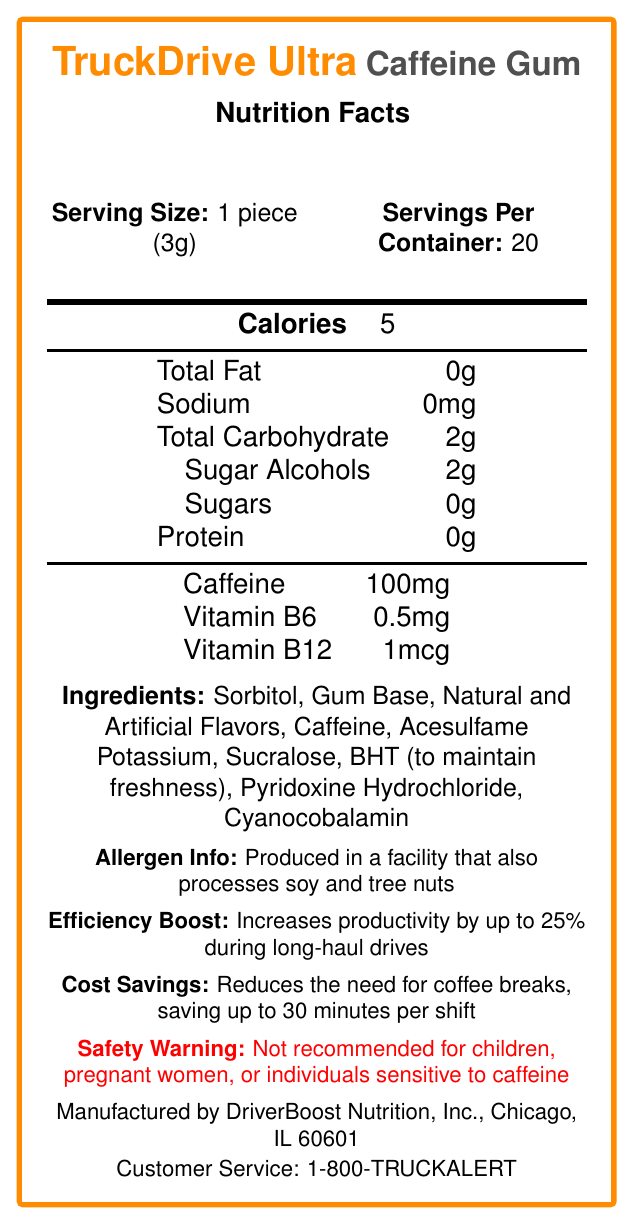what is the serving size? The document states that the serving size is 1 piece (3g).
Answer: 1 piece (3g) how many servings are there per container? According to the document, there are 20 servings per container.
Answer: 20 what is the amount of caffeine per serving? The document specifies that each serving contains 100mg of caffeine.
Answer: 100mg how many calories are in one serving? The document states that one serving contains 5 calories.
Answer: 5 what are the main ingredients of the product? The document lists the ingredients as Sorbitol, Gum Base, Natural and Artificial Flavors, Caffeine, Acesulfame Potassium, Sucralose, BHT (to maintain freshness), Pyridoxine Hydrochloride, Cyanocobalamin.
Answer: Sorbitol, Gum Base, Natural and Artificial Flavors, Caffeine, Acesulfame Potassium, Sucralose, BHT (to maintain freshness), Pyridoxine Hydrochloride, Cyanocobalamin what is the peak alertness duration provided by this gum? The document mentions that the peak alertness duration is 3-4 hours.
Answer: 3-4 hours what type of vitamins are included in TruckDrive Ultra Caffeine Gum? The document lists Vitamin B6 (0.5mg) and Vitamin B12 (1mcg) among the nutrients.
Answer: Vitamin B6 and Vitamin B12 what is the recommended chew time for this gum? The recommended chew time mentioned in the document is 15-20 minutes.
Answer: 15-20 minutes are there any allergens present in the product? The document states that the product is produced in a facility that also processes soy and tree nuts.
Answer: Produced in a facility that also processes soy and tree nuts what is the advised storage method for this product? According to the document, the storage instructions are to store the gum in a cool, dry place away from direct sunlight.
Answer: Store in a cool, dry place away from direct sunlight how much sugar is in one serving? The document indicates that there are 0 grams of sugar per serving.
Answer: 0g which of the following is not an ingredient in TruckDrive Ultra Caffeine Gum? A. Sorbitol B. Gum Base C. Caffeine D. Aspartame E. Sucralose The list of ingredients in the document does not include aspartame.
Answer: D. Aspartame what percentage of recycled materials is used in the packaging? A. 20% B. 30% C. 40% D. 50% The document states that the packaging is made from 30% recycled materials.
Answer: B. 30% is this product suitable for drivers? The document claims that the product is suitable for drivers.
Answer: Yes describe the main idea of the document. The document provides detailed information about the nutritional content, recommended usage, and benefits of TruckDrive Ultra Caffeine Gum while highlighting its target audience and necessary precautions.
Answer: The document describes the nutrition facts, ingredients, and benefits of "TruckDrive Ultra Caffeine Gum," which is designed to enhance alertness and productivity for long-haul drivers, along with providing necessary safety warnings and storage instructions. what is the manufacturing date of this product? The document does not provide information about the manufacturing date.
Answer: Cannot be determined 